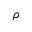<formula> <loc_0><loc_0><loc_500><loc_500>\rho</formula> 